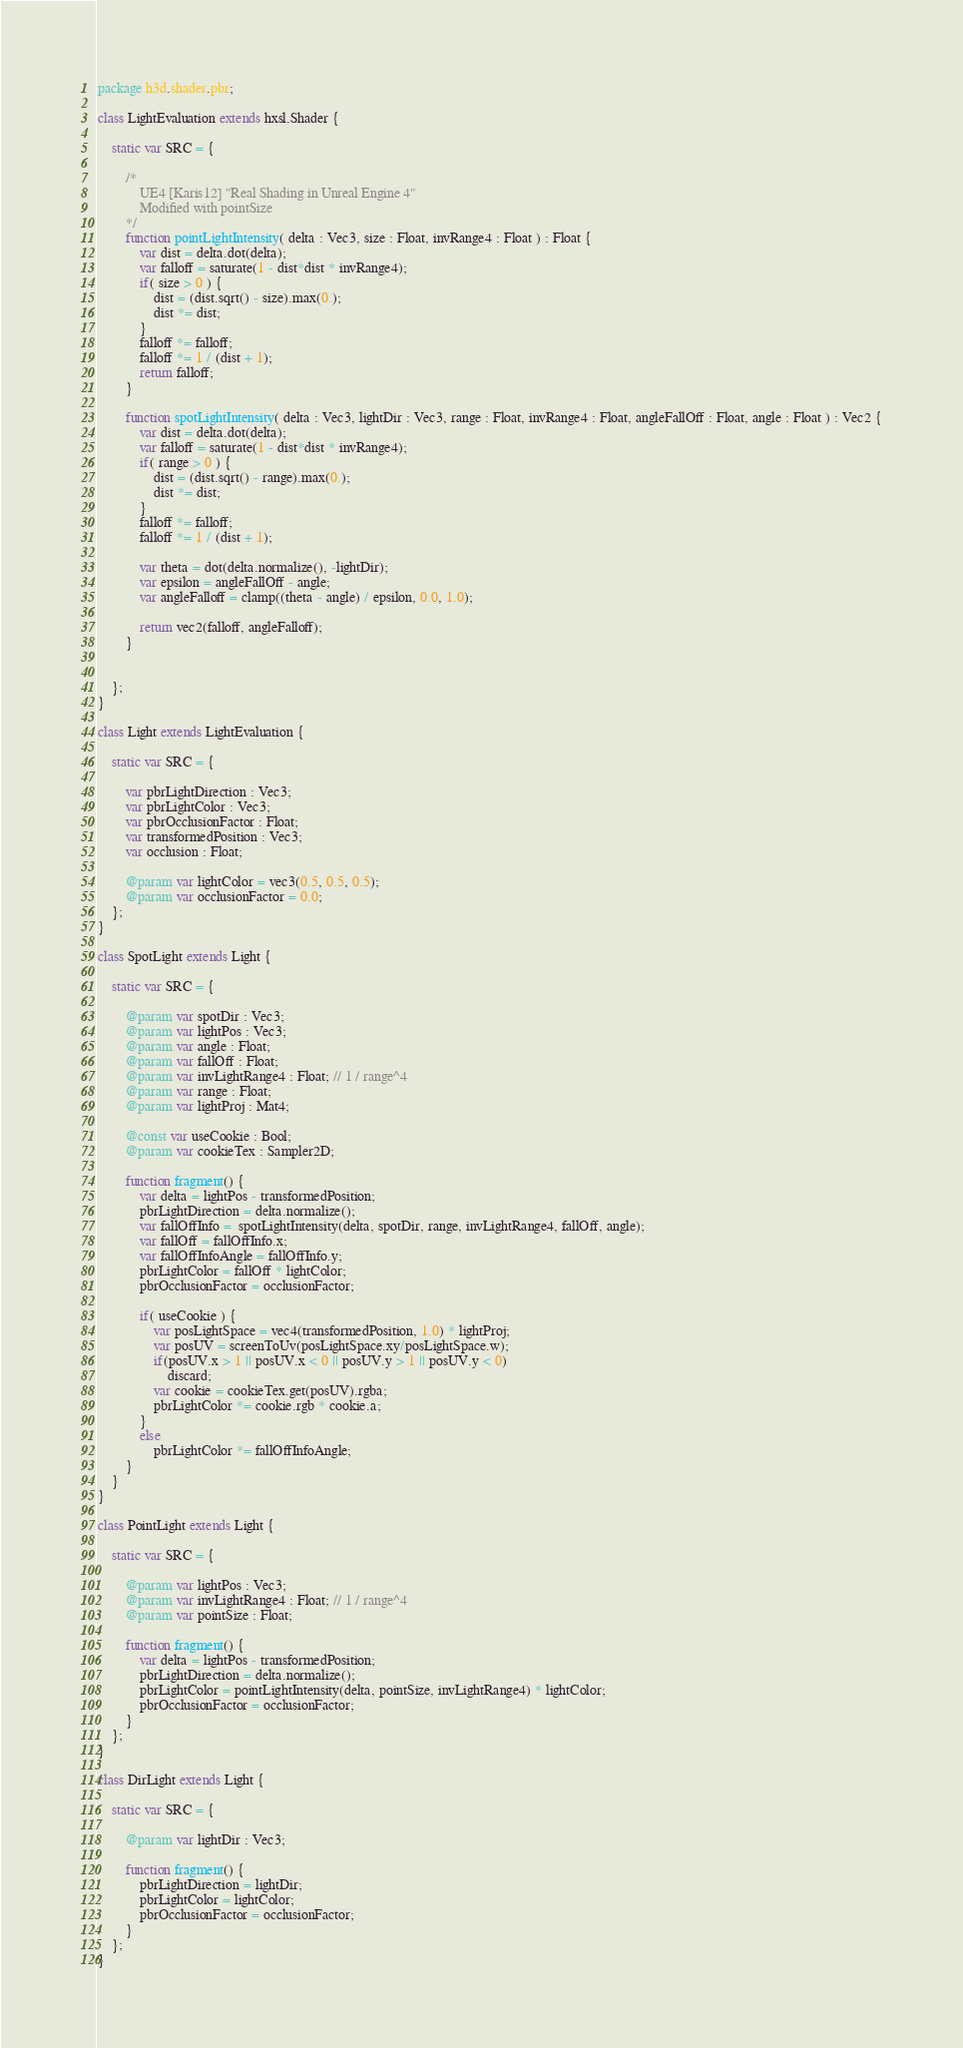Convert code to text. <code><loc_0><loc_0><loc_500><loc_500><_Haxe_>package h3d.shader.pbr;

class LightEvaluation extends hxsl.Shader {

	static var SRC = {

		/*
			UE4 [Karis12] "Real Shading in Unreal Engine 4"
			Modified with pointSize
		*/
		function pointLightIntensity( delta : Vec3, size : Float, invRange4 : Float ) : Float {
			var dist = delta.dot(delta);
			var falloff = saturate(1 - dist*dist * invRange4);
			if( size > 0 ) {
				dist = (dist.sqrt() - size).max(0.);
				dist *= dist;
			}
			falloff *= falloff;
			falloff *= 1 / (dist + 1);
			return falloff;
		}

		function spotLightIntensity( delta : Vec3, lightDir : Vec3, range : Float, invRange4 : Float, angleFallOff : Float, angle : Float ) : Vec2 {
			var dist = delta.dot(delta);
			var falloff = saturate(1 - dist*dist * invRange4);
			if( range > 0 ) {
				dist = (dist.sqrt() - range).max(0.);
				dist *= dist;
			}
			falloff *= falloff;
			falloff *= 1 / (dist + 1);

			var theta = dot(delta.normalize(), -lightDir);
			var epsilon = angleFallOff - angle;
			var angleFalloff = clamp((theta - angle) / epsilon, 0.0, 1.0);

			return vec2(falloff, angleFalloff);
		}


	};
}

class Light extends LightEvaluation {

	static var SRC = {

		var pbrLightDirection : Vec3;
		var pbrLightColor : Vec3;
		var pbrOcclusionFactor : Float;
		var transformedPosition : Vec3;
		var occlusion : Float;

		@param var lightColor = vec3(0.5, 0.5, 0.5);
		@param var occlusionFactor = 0.0;
	};
}

class SpotLight extends Light {

	static var SRC = {

		@param var spotDir : Vec3;
		@param var lightPos : Vec3;
		@param var angle : Float;
		@param var fallOff : Float;
		@param var invLightRange4 : Float; // 1 / range^4
		@param var range : Float;
		@param var lightProj : Mat4;

		@const var useCookie : Bool;
		@param var cookieTex : Sampler2D;

		function fragment() {
			var delta = lightPos - transformedPosition;
			pbrLightDirection = delta.normalize();
			var fallOffInfo =  spotLightIntensity(delta, spotDir, range, invLightRange4, fallOff, angle);
			var fallOff = fallOffInfo.x;
			var fallOffInfoAngle = fallOffInfo.y;
			pbrLightColor = fallOff * lightColor;
			pbrOcclusionFactor = occlusionFactor;

			if( useCookie ) {
				var posLightSpace = vec4(transformedPosition, 1.0) * lightProj;
				var posUV = screenToUv(posLightSpace.xy/posLightSpace.w);
				if(posUV.x > 1 || posUV.x < 0 || posUV.y > 1 || posUV.y < 0)
					discard;
				var cookie = cookieTex.get(posUV).rgba;
				pbrLightColor *= cookie.rgb * cookie.a;
			}
			else
				pbrLightColor *= fallOffInfoAngle;
		}
	}
}

class PointLight extends Light {

	static var SRC = {

		@param var lightPos : Vec3;
		@param var invLightRange4 : Float; // 1 / range^4
		@param var pointSize : Float;

		function fragment() {
			var delta = lightPos - transformedPosition;
			pbrLightDirection = delta.normalize();
			pbrLightColor = pointLightIntensity(delta, pointSize, invLightRange4) * lightColor;
			pbrOcclusionFactor = occlusionFactor;
		}
	};
}

class DirLight extends Light {

	static var SRC = {

		@param var lightDir : Vec3;

		function fragment() {
			pbrLightDirection = lightDir;
			pbrLightColor = lightColor;
			pbrOcclusionFactor = occlusionFactor;
		}
	};
}
</code> 